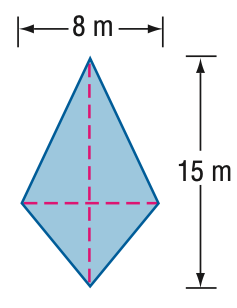Question: Find the area of the kite.
Choices:
A. 40
B. 60
C. 80
D. 120
Answer with the letter. Answer: B 